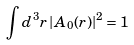<formula> <loc_0><loc_0><loc_500><loc_500>\int d ^ { 3 } r \left | A _ { 0 } ( r ) \right | ^ { 2 } = 1</formula> 